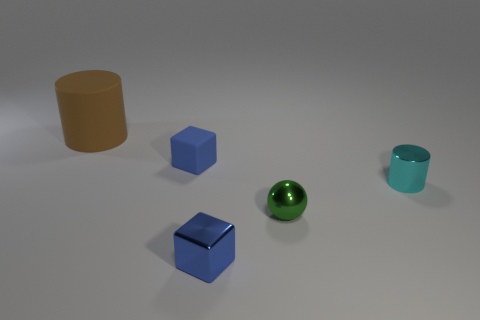What shape is the small metal thing that is the same color as the matte cube?
Make the answer very short. Cube. How many brown things are there?
Offer a terse response. 1. What shape is the small cyan thing?
Your response must be concise. Cylinder. How many blocks are the same size as the metal cylinder?
Your answer should be compact. 2. Does the big brown thing have the same shape as the small blue rubber object?
Give a very brief answer. No. There is a small cube that is in front of the cylinder on the right side of the brown object; what is its color?
Provide a succinct answer. Blue. What size is the thing that is on the right side of the small blue rubber block and behind the small green sphere?
Provide a succinct answer. Small. Is there anything else of the same color as the big rubber cylinder?
Make the answer very short. No. There is a blue thing that is the same material as the small green ball; what is its shape?
Provide a short and direct response. Cube. There is a small cyan shiny thing; does it have the same shape as the thing that is in front of the green shiny sphere?
Keep it short and to the point. No. 